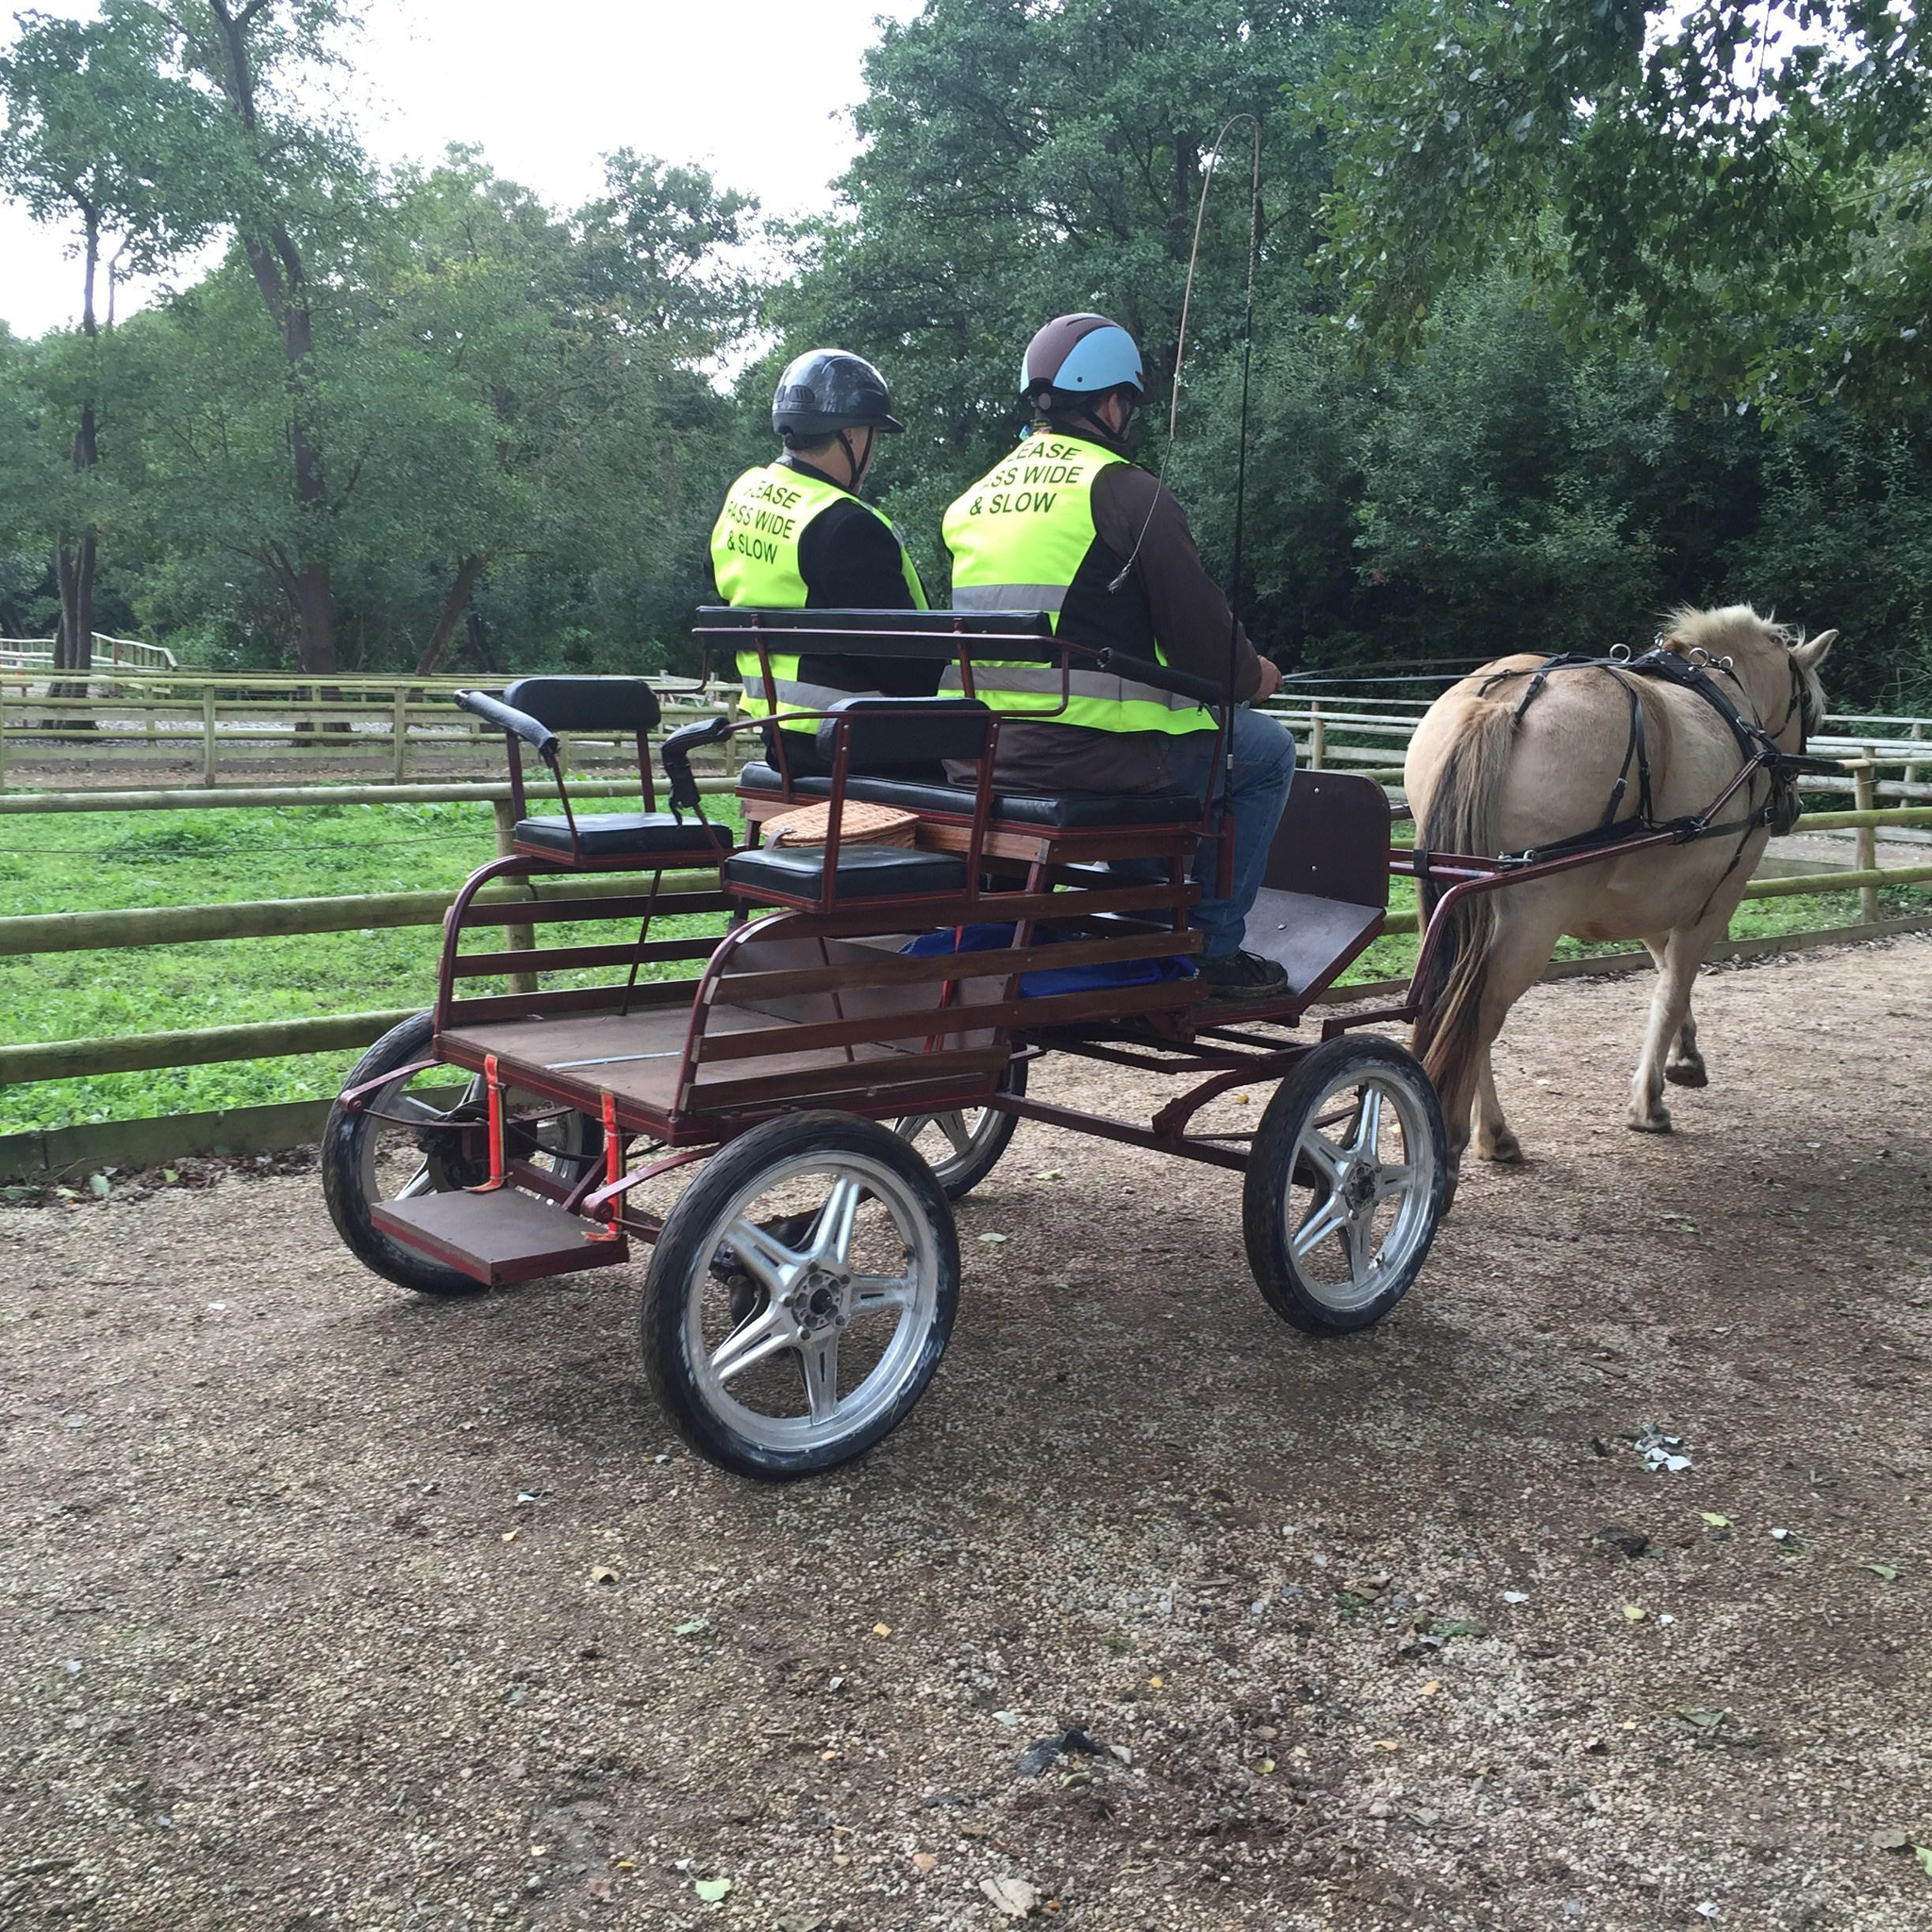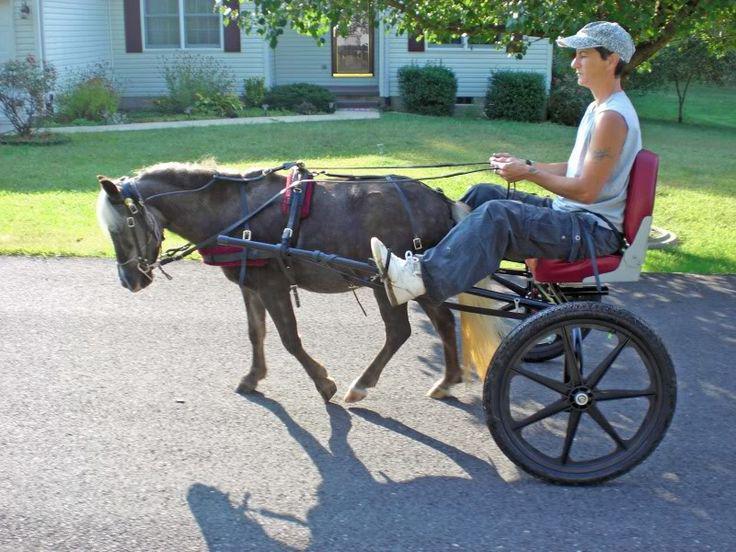The first image is the image on the left, the second image is the image on the right. For the images displayed, is the sentence "There is a human riding a carriage." factually correct? Answer yes or no. Yes. 